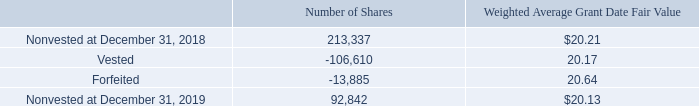Restricted Share Awards
During the years ended December 31, 2017, pursuant to the Company’s 2016 Incentive Plan and 2005 Incentive Plan, the Company granted RSAs. The awards have requisite service periods of three years and vest in increments of 33% on the anniversary of the grant dates. Under each arrangement, shares are issued without direct cost to the employee. RSAs granted to our board vest one year from grant or as of the next annual shareholders meeting, whichever is earlier. The Company estimates the fair value of the RSAs based upon the market price of the Company’s stock at the date of grant. The RSA grants provide for the payment of dividends on the Company’s common stock, if any, to the participant during the requisite service period, and the participant has voting rights for each share of common stock. The Company recognizes compensation expense for RSAs on a straight-line basis over the requisite service period.
A summary of nonvested RSAs is as follows:
During the year ended December 31, 2019, a total of 106,610 RSAs vested. The Company withheld 32,371 of those shares to pay the employees’ portion of the minimum payroll withholding taxes.
How many shares did the company withhold to pay  the employees' portion of the minimum payroll withholding taxes? 32,371. What was the number of nonvested shares were there in 2018? 213,337. What was the Weighted Average Grant Date Fair Value of nonvested shares in 2018? $20.21. What is the change in nonvested shares between 2018 and 2019? 92,842-213,337
Answer: -120495. What was the difference in Weighted Average Grant Date Fair Value between Vested and Forfeited shares? 20.64-20.17
Answer: 0.47. What was the difference between the Weighted Average Grant Date Fair Value of nonvested shares in 2019 and forfeited shares? 20.64-20.13
Answer: 0.51. 